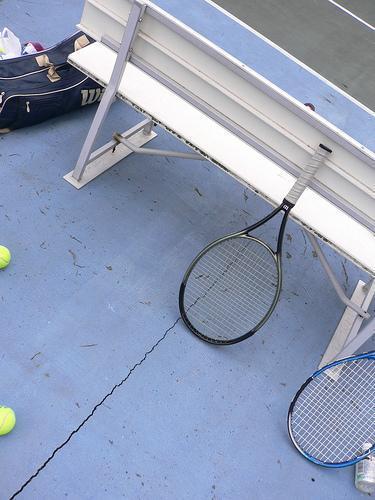How many tennis rackets are there?
Give a very brief answer. 2. 